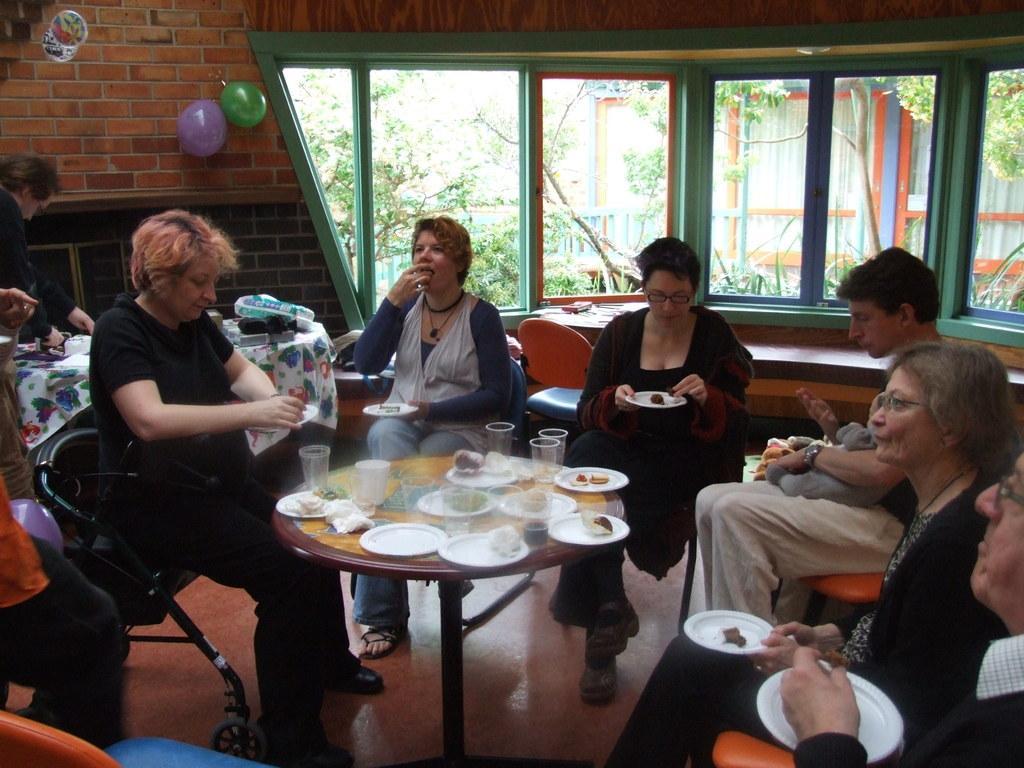Describe this image in one or two sentences. There are many persons sitting. They are holding plates. On front of them there is a table. On the table there are glasses, plates, and some food items. In the background there is a brick wall. On the wall there are balloons. Also there are windows and other table. in the background there are trees and other building. 